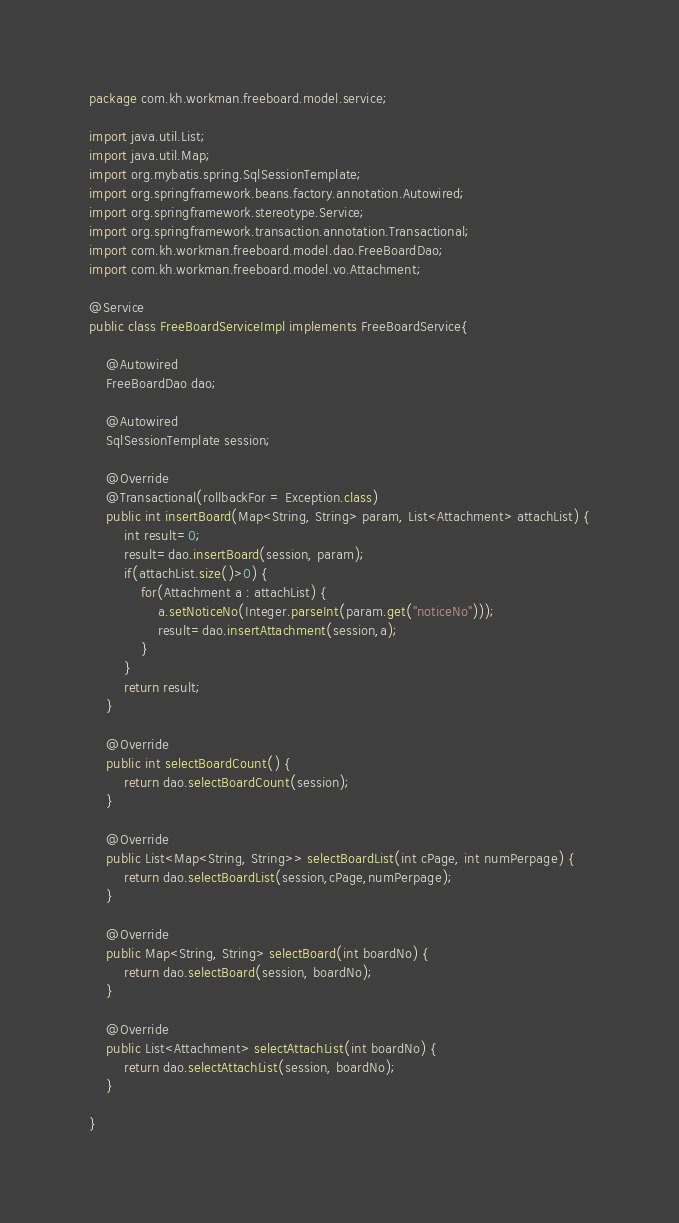Convert code to text. <code><loc_0><loc_0><loc_500><loc_500><_Java_>package com.kh.workman.freeboard.model.service;

import java.util.List;
import java.util.Map;
import org.mybatis.spring.SqlSessionTemplate;
import org.springframework.beans.factory.annotation.Autowired;
import org.springframework.stereotype.Service;
import org.springframework.transaction.annotation.Transactional;
import com.kh.workman.freeboard.model.dao.FreeBoardDao;
import com.kh.workman.freeboard.model.vo.Attachment;

@Service
public class FreeBoardServiceImpl implements FreeBoardService{

	@Autowired
	FreeBoardDao dao;
	
	@Autowired
	SqlSessionTemplate session;
	
	@Override
	@Transactional(rollbackFor = Exception.class) 
	public int insertBoard(Map<String, String> param, List<Attachment> attachList) {
		int result=0;
		result=dao.insertBoard(session, param);
		if(attachList.size()>0) {
			for(Attachment a : attachList) {
				a.setNoticeNo(Integer.parseInt(param.get("noticeNo")));
				result=dao.insertAttachment(session,a);
			}
		}		
		return result;
	}

	@Override
	public int selectBoardCount() {
		return dao.selectBoardCount(session);
	}

	@Override
	public List<Map<String, String>> selectBoardList(int cPage, int numPerpage) {
		return dao.selectBoardList(session,cPage,numPerpage);
	}

	@Override
	public Map<String, String> selectBoard(int boardNo) {
		return dao.selectBoard(session, boardNo);
	}

	@Override
	public List<Attachment> selectAttachList(int boardNo) {
		return dao.selectAttachList(session, boardNo);
	}
	
}
</code> 